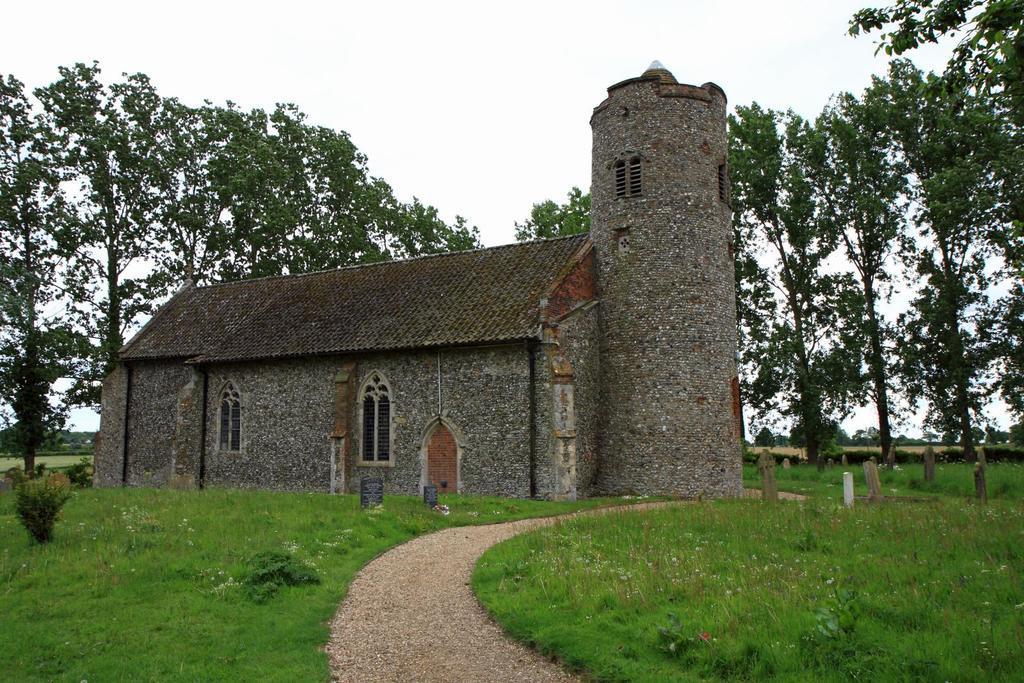In one or two sentences, can you explain what this image depicts? In this picture I can see the path and the grass in front and in the middle of this picture I can see a building, few tombstones, plants and the trees. In the background I can see the sky. 